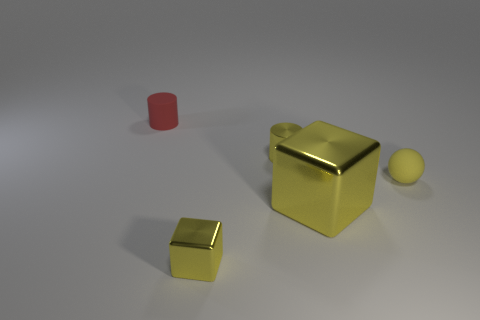Do the big yellow cube and the tiny sphere have the same material?
Ensure brevity in your answer.  No. How many brown things are either large metallic things or tiny things?
Keep it short and to the point. 0. Is the number of red things that are behind the large yellow metal object greater than the number of small shiny balls?
Your answer should be compact. Yes. Is there another tiny ball of the same color as the small matte ball?
Provide a succinct answer. No. Is the tiny metal cube the same color as the tiny metal cylinder?
Provide a succinct answer. Yes. How many objects are either small shiny cylinders or metallic objects that are behind the large shiny object?
Your response must be concise. 1. There is a small rubber object that is left of the tiny yellow thing that is behind the tiny matte sphere; how many tiny cubes are left of it?
Make the answer very short. 0. There is a cylinder that is the same color as the big shiny object; what is it made of?
Make the answer very short. Metal. What number of matte balls are there?
Keep it short and to the point. 1. There is a cylinder on the right side of the red thing; does it have the same size as the red thing?
Your response must be concise. Yes. 